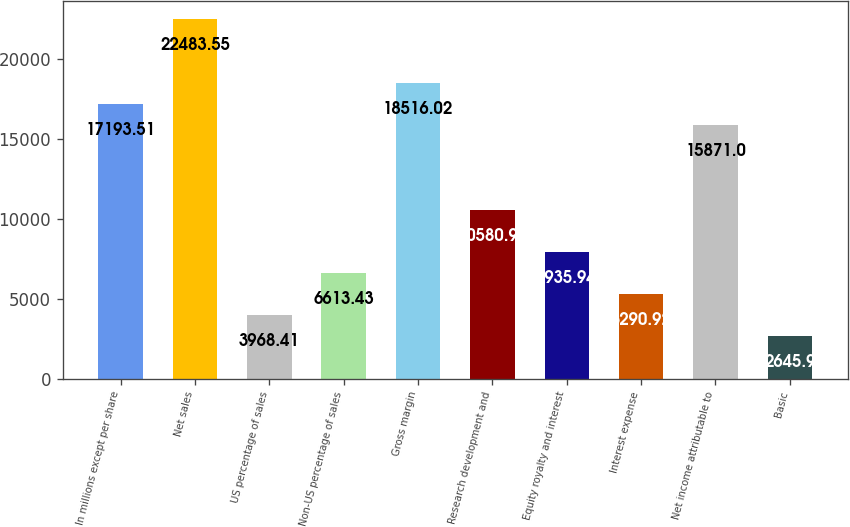Convert chart. <chart><loc_0><loc_0><loc_500><loc_500><bar_chart><fcel>In millions except per share<fcel>Net sales<fcel>US percentage of sales<fcel>Non-US percentage of sales<fcel>Gross margin<fcel>Research development and<fcel>Equity royalty and interest<fcel>Interest expense<fcel>Net income attributable to<fcel>Basic<nl><fcel>17193.5<fcel>22483.5<fcel>3968.41<fcel>6613.43<fcel>18516<fcel>10581<fcel>7935.94<fcel>5290.92<fcel>15871<fcel>2645.9<nl></chart> 